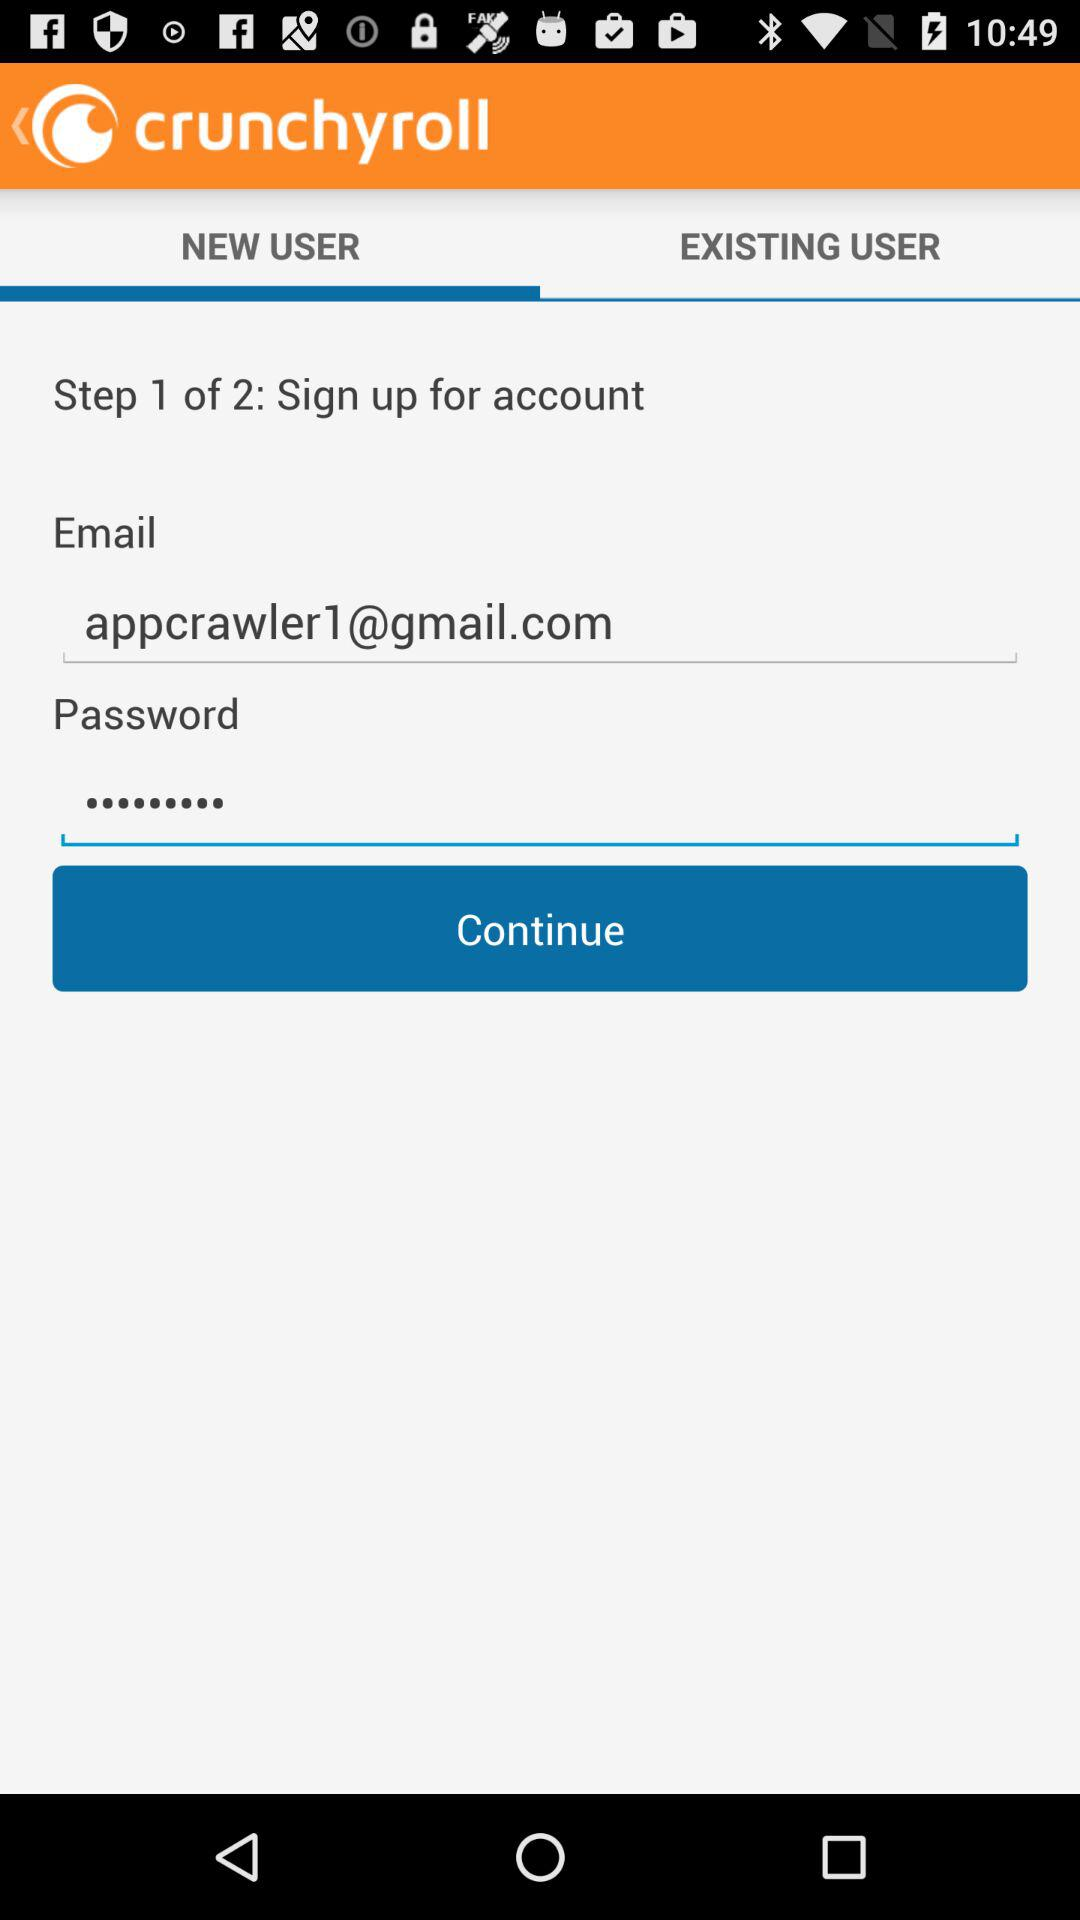What is the email address? The email address is appcrawler1@gmail.com. 